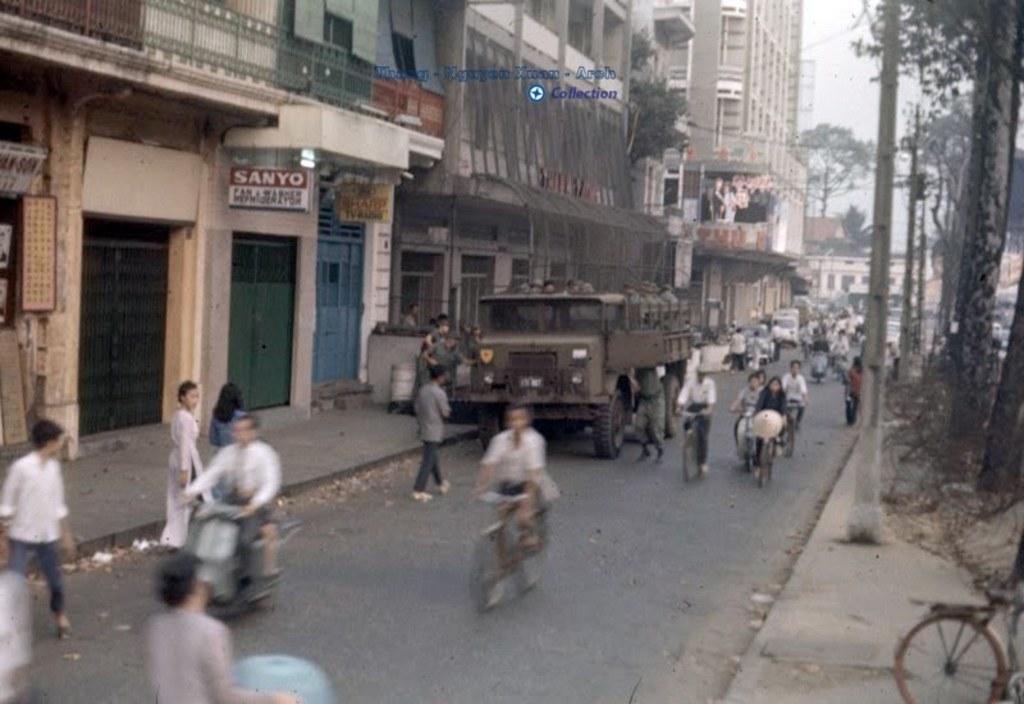Can you describe this image briefly? In this image we can see vehicles moving on the road and people walking on the road. On the right side of the image we can see a cycle parked here, trees, poles and wires. On the left side of the image we can see buildings, board and sky in the background. 